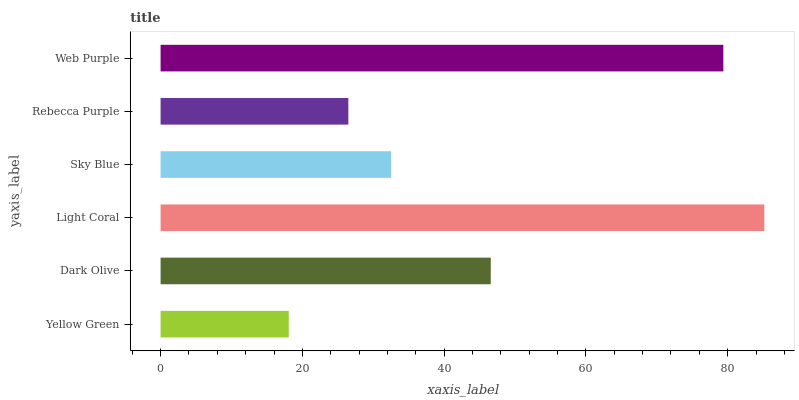Is Yellow Green the minimum?
Answer yes or no. Yes. Is Light Coral the maximum?
Answer yes or no. Yes. Is Dark Olive the minimum?
Answer yes or no. No. Is Dark Olive the maximum?
Answer yes or no. No. Is Dark Olive greater than Yellow Green?
Answer yes or no. Yes. Is Yellow Green less than Dark Olive?
Answer yes or no. Yes. Is Yellow Green greater than Dark Olive?
Answer yes or no. No. Is Dark Olive less than Yellow Green?
Answer yes or no. No. Is Dark Olive the high median?
Answer yes or no. Yes. Is Sky Blue the low median?
Answer yes or no. Yes. Is Light Coral the high median?
Answer yes or no. No. Is Web Purple the low median?
Answer yes or no. No. 